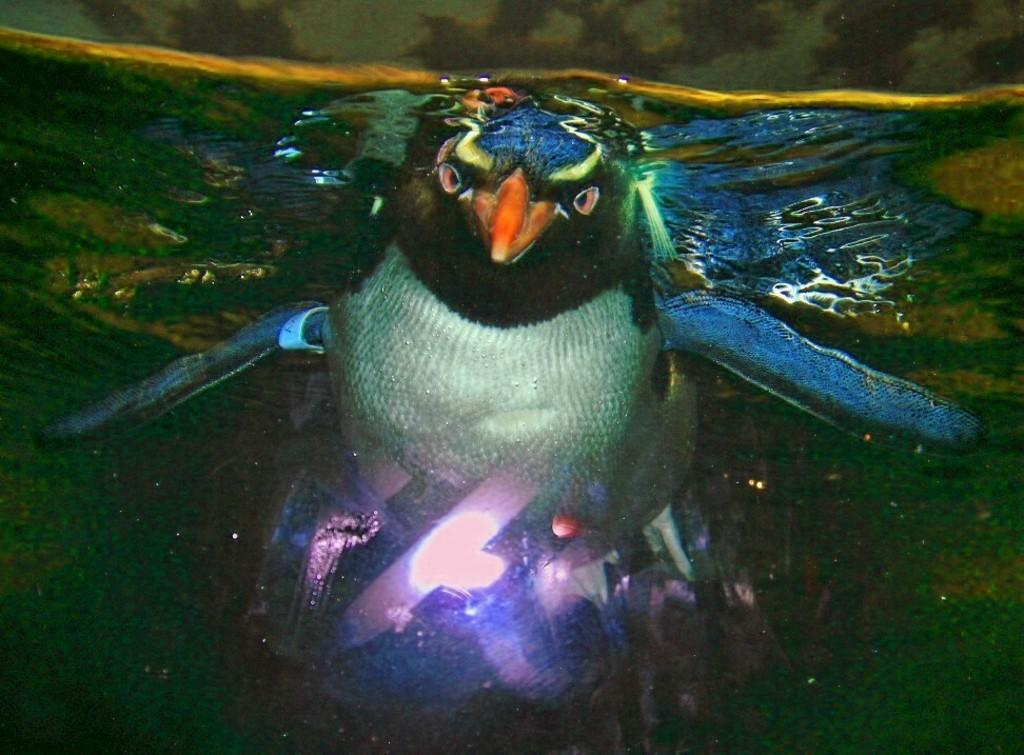What is the main subject of the image? There is a painting or photograph of an eagle in the image. What colors are used to depict the eagle? The eagle is blue and white in color. Where is the eagle located in the image? The eagle is depicted underwater. What type of corn is being used as glue in the image? There is no corn or glue present in the image; it features a painting or photograph of an eagle underwater. 